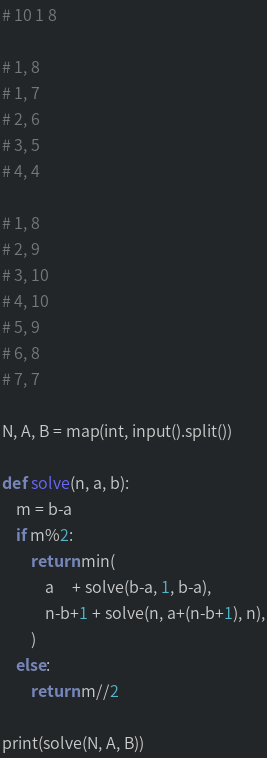Convert code to text. <code><loc_0><loc_0><loc_500><loc_500><_Python_># 10 1 8 

# 1, 8
# 1, 7
# 2, 6
# 3, 5
# 4, 4

# 1, 8
# 2, 9
# 3, 10
# 4, 10
# 5, 9
# 6, 8
# 7, 7

N, A, B = map(int, input().split())

def solve(n, a, b):
    m = b-a
    if m%2:
        return min(
            a     + solve(b-a, 1, b-a),
            n-b+1 + solve(n, a+(n-b+1), n),
        )
    else:
        return m//2

print(solve(N, A, B))</code> 